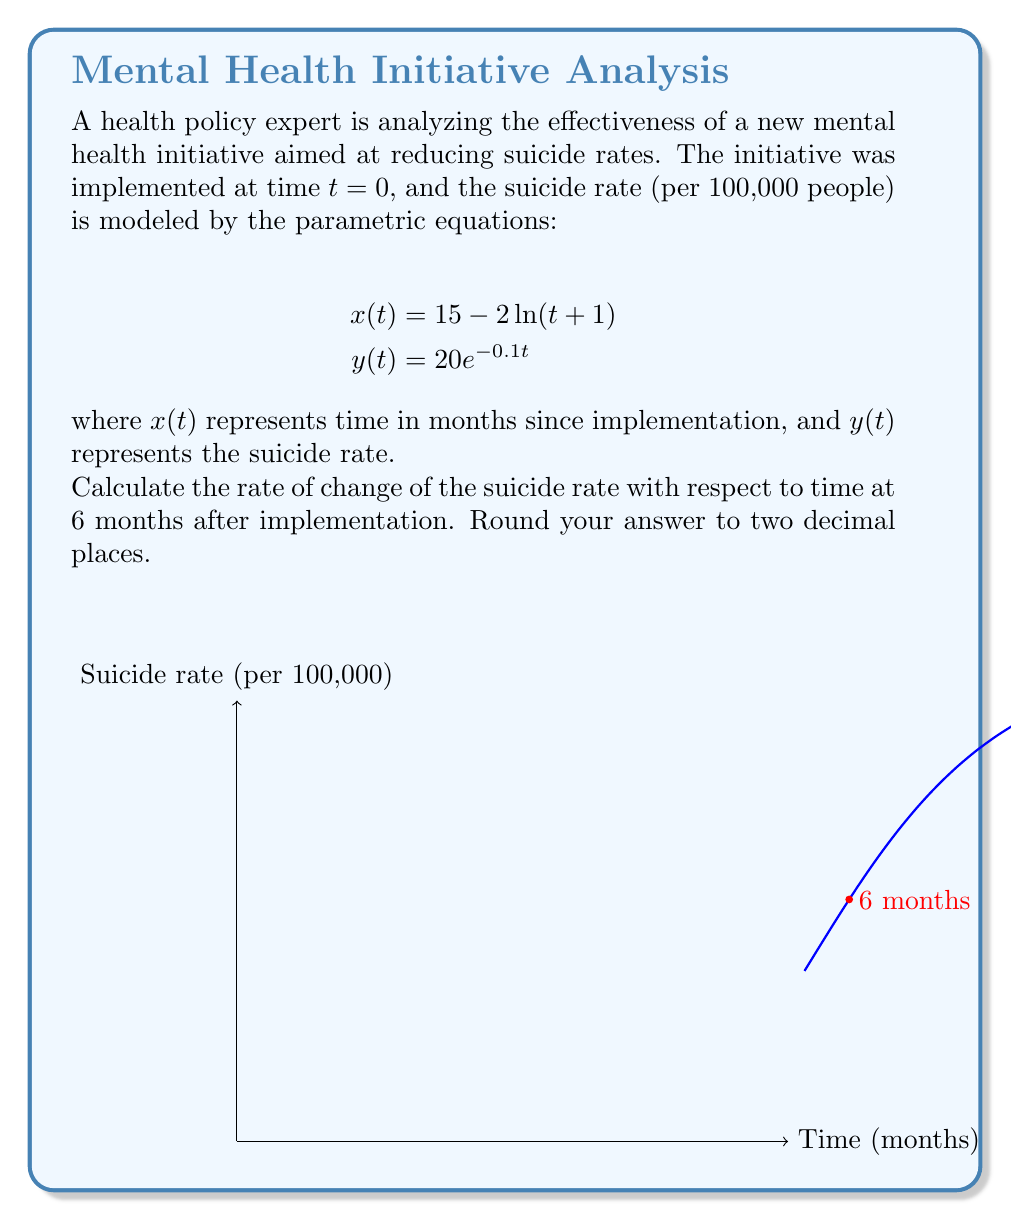Teach me how to tackle this problem. Let's approach this step-by-step:

1) We need to find $\frac{dy}{dx}$ at $t=6$. We can use the chain rule:

   $$\frac{dy}{dx} = \frac{dy/dt}{dx/dt}$$

2) First, let's calculate $\frac{dx}{dt}$ and $\frac{dy}{dt}$:

   $$\frac{dx}{dt} = -\frac{2}{t+1}$$
   
   $$\frac{dy}{dt} = -2e^{-0.1t}$$

3) Now, we need to evaluate these at $t=6$:

   $$\left.\frac{dx}{dt}\right|_{t=6} = -\frac{2}{6+1} = -\frac{2}{7}$$
   
   $$\left.\frac{dy}{dt}\right|_{t=6} = -2e^{-0.1(6)} = -2e^{-0.6}$$

4) Now we can calculate $\frac{dy}{dx}$ at $t=6$:

   $$\left.\frac{dy}{dx}\right|_{t=6} = \frac{-2e^{-0.6}}{-\frac{2}{7}} = 7e^{-0.6}$$

5) Evaluating this:

   $$7e^{-0.6} \approx 3.8422$$

6) Rounding to two decimal places:

   $$3.84$$

This positive value indicates that as time increases, the suicide rate is increasing at this point, which might suggest the need for policy adjustments.
Answer: 3.84 per 100,000 per month 